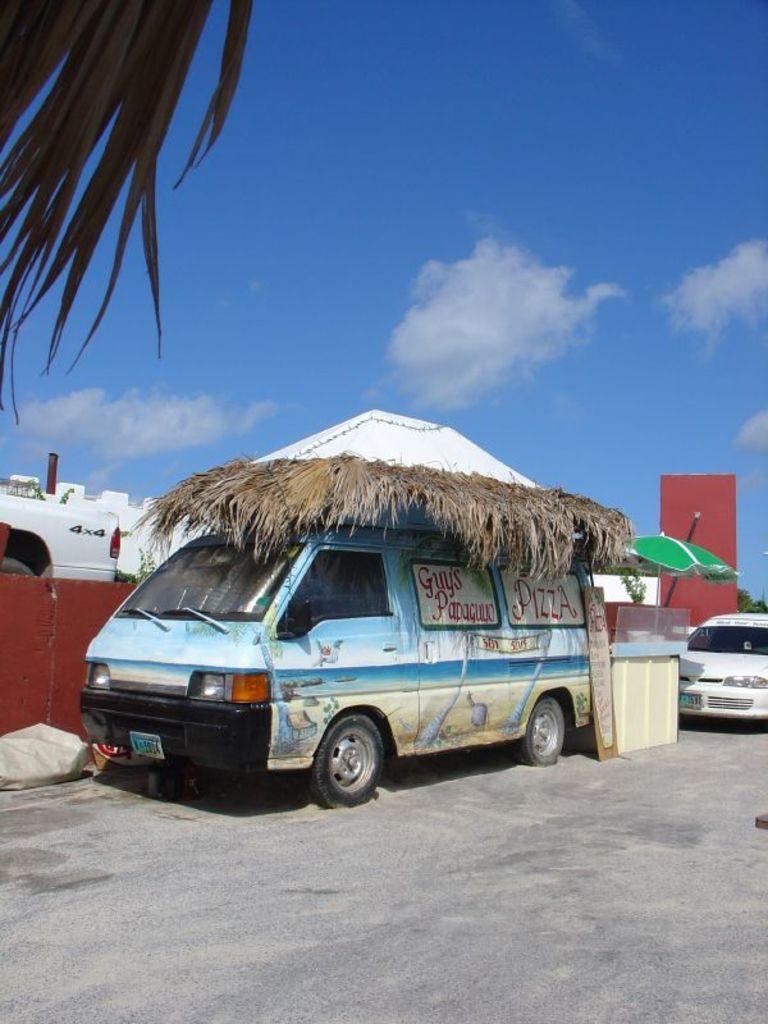How would you summarize this image in a sentence or two? In this image I can see the ground, few vehicles on the ground, a green colored tent and few brown colored leaves on the vehicle. In the background I can see few trees, a building and the sky. 